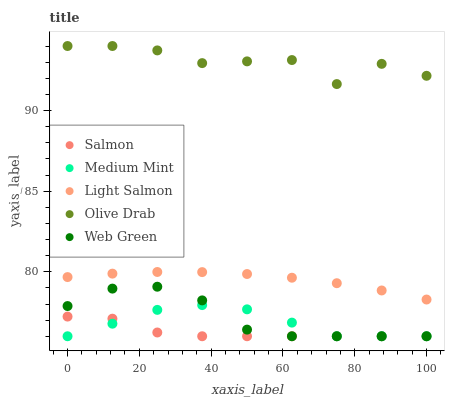Does Salmon have the minimum area under the curve?
Answer yes or no. Yes. Does Olive Drab have the maximum area under the curve?
Answer yes or no. Yes. Does Light Salmon have the minimum area under the curve?
Answer yes or no. No. Does Light Salmon have the maximum area under the curve?
Answer yes or no. No. Is Light Salmon the smoothest?
Answer yes or no. Yes. Is Olive Drab the roughest?
Answer yes or no. Yes. Is Salmon the smoothest?
Answer yes or no. No. Is Salmon the roughest?
Answer yes or no. No. Does Medium Mint have the lowest value?
Answer yes or no. Yes. Does Light Salmon have the lowest value?
Answer yes or no. No. Does Olive Drab have the highest value?
Answer yes or no. Yes. Does Light Salmon have the highest value?
Answer yes or no. No. Is Web Green less than Light Salmon?
Answer yes or no. Yes. Is Olive Drab greater than Salmon?
Answer yes or no. Yes. Does Salmon intersect Medium Mint?
Answer yes or no. Yes. Is Salmon less than Medium Mint?
Answer yes or no. No. Is Salmon greater than Medium Mint?
Answer yes or no. No. Does Web Green intersect Light Salmon?
Answer yes or no. No. 